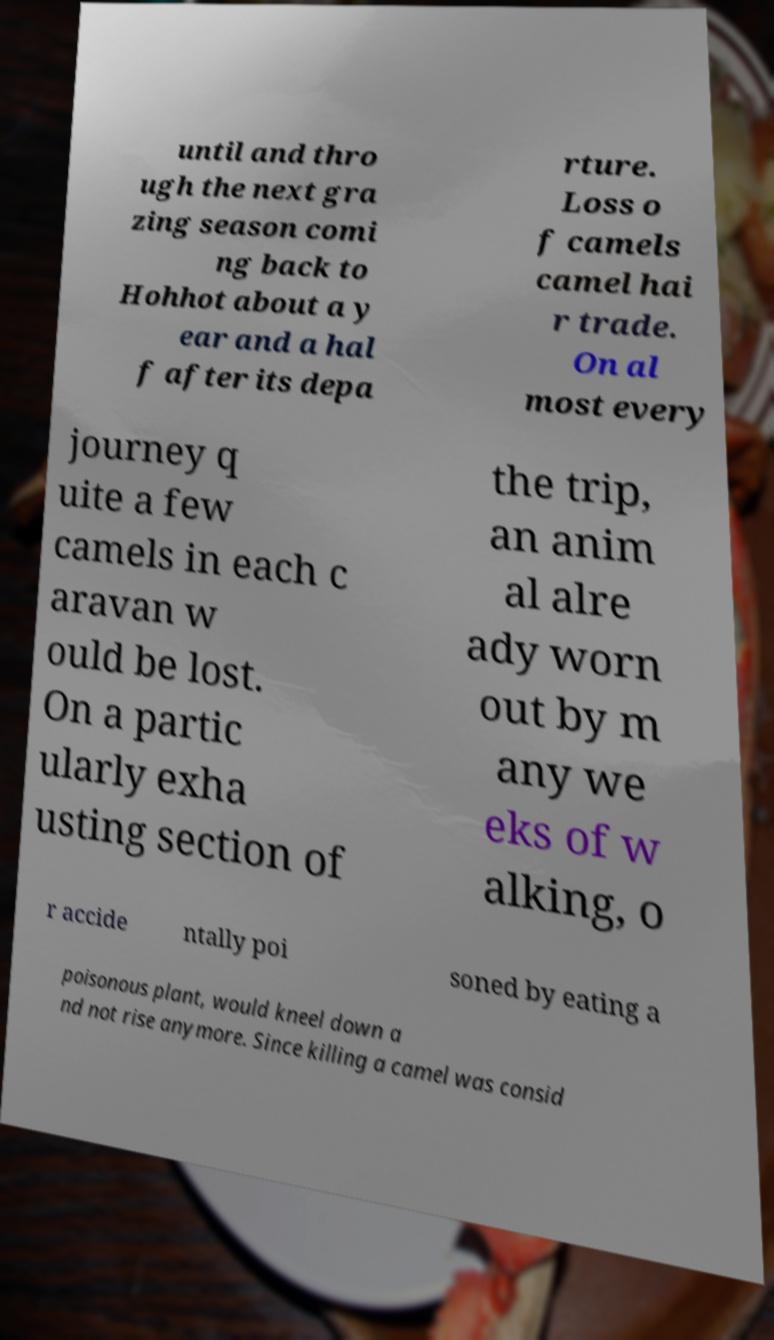What messages or text are displayed in this image? I need them in a readable, typed format. until and thro ugh the next gra zing season comi ng back to Hohhot about a y ear and a hal f after its depa rture. Loss o f camels camel hai r trade. On al most every journey q uite a few camels in each c aravan w ould be lost. On a partic ularly exha usting section of the trip, an anim al alre ady worn out by m any we eks of w alking, o r accide ntally poi soned by eating a poisonous plant, would kneel down a nd not rise anymore. Since killing a camel was consid 